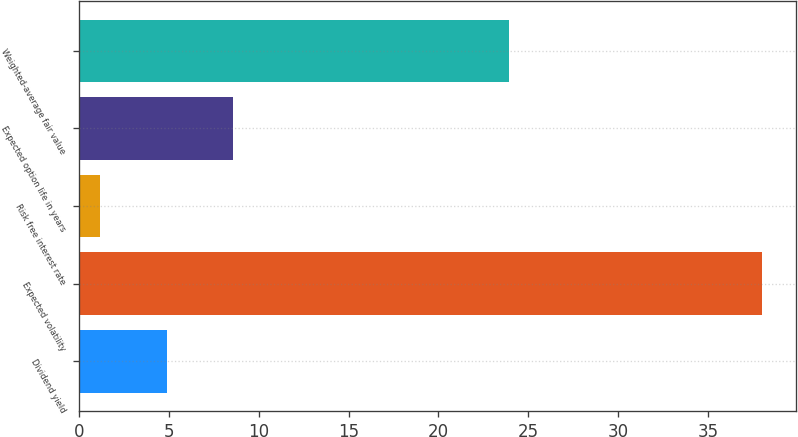<chart> <loc_0><loc_0><loc_500><loc_500><bar_chart><fcel>Dividend yield<fcel>Expected volatility<fcel>Risk free interest rate<fcel>Expected option life in years<fcel>Weighted-average fair value<nl><fcel>4.88<fcel>38<fcel>1.2<fcel>8.56<fcel>23.93<nl></chart> 